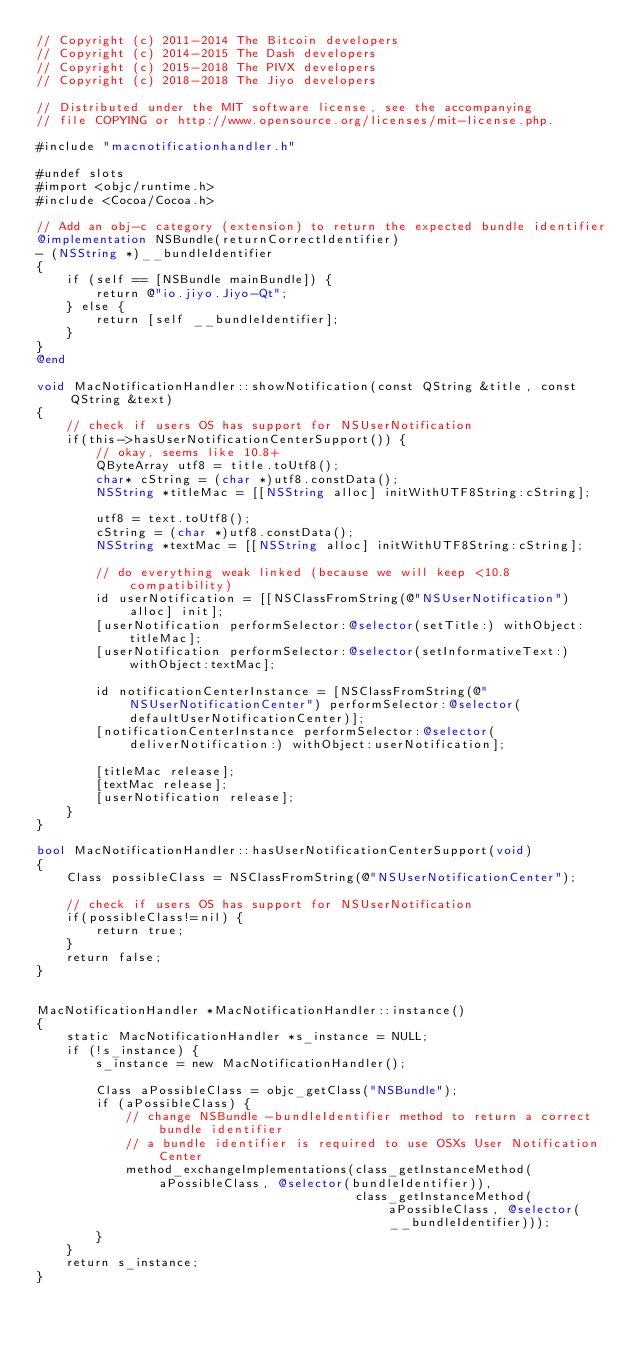<code> <loc_0><loc_0><loc_500><loc_500><_ObjectiveC_>// Copyright (c) 2011-2014 The Bitcoin developers
// Copyright (c) 2014-2015 The Dash developers
// Copyright (c) 2015-2018 The PIVX developers
// Copyright (c) 2018-2018 The Jiyo developers

// Distributed under the MIT software license, see the accompanying
// file COPYING or http://www.opensource.org/licenses/mit-license.php.

#include "macnotificationhandler.h"

#undef slots
#import <objc/runtime.h>
#include <Cocoa/Cocoa.h>

// Add an obj-c category (extension) to return the expected bundle identifier
@implementation NSBundle(returnCorrectIdentifier)
- (NSString *)__bundleIdentifier
{
    if (self == [NSBundle mainBundle]) {
        return @"io.jiyo.Jiyo-Qt";
    } else {
        return [self __bundleIdentifier];
    }
}
@end

void MacNotificationHandler::showNotification(const QString &title, const QString &text)
{
    // check if users OS has support for NSUserNotification
    if(this->hasUserNotificationCenterSupport()) {
        // okay, seems like 10.8+
        QByteArray utf8 = title.toUtf8();
        char* cString = (char *)utf8.constData();
        NSString *titleMac = [[NSString alloc] initWithUTF8String:cString];

        utf8 = text.toUtf8();
        cString = (char *)utf8.constData();
        NSString *textMac = [[NSString alloc] initWithUTF8String:cString];

        // do everything weak linked (because we will keep <10.8 compatibility)
        id userNotification = [[NSClassFromString(@"NSUserNotification") alloc] init];
        [userNotification performSelector:@selector(setTitle:) withObject:titleMac];
        [userNotification performSelector:@selector(setInformativeText:) withObject:textMac];

        id notificationCenterInstance = [NSClassFromString(@"NSUserNotificationCenter") performSelector:@selector(defaultUserNotificationCenter)];
        [notificationCenterInstance performSelector:@selector(deliverNotification:) withObject:userNotification];

        [titleMac release];
        [textMac release];
        [userNotification release];
    }
}

bool MacNotificationHandler::hasUserNotificationCenterSupport(void)
{
    Class possibleClass = NSClassFromString(@"NSUserNotificationCenter");

    // check if users OS has support for NSUserNotification
    if(possibleClass!=nil) {
        return true;
    }
    return false;
}


MacNotificationHandler *MacNotificationHandler::instance()
{
    static MacNotificationHandler *s_instance = NULL;
    if (!s_instance) {
        s_instance = new MacNotificationHandler();
        
        Class aPossibleClass = objc_getClass("NSBundle");
        if (aPossibleClass) {
            // change NSBundle -bundleIdentifier method to return a correct bundle identifier
            // a bundle identifier is required to use OSXs User Notification Center
            method_exchangeImplementations(class_getInstanceMethod(aPossibleClass, @selector(bundleIdentifier)),
                                           class_getInstanceMethod(aPossibleClass, @selector(__bundleIdentifier)));
        }
    }
    return s_instance;
}
</code> 